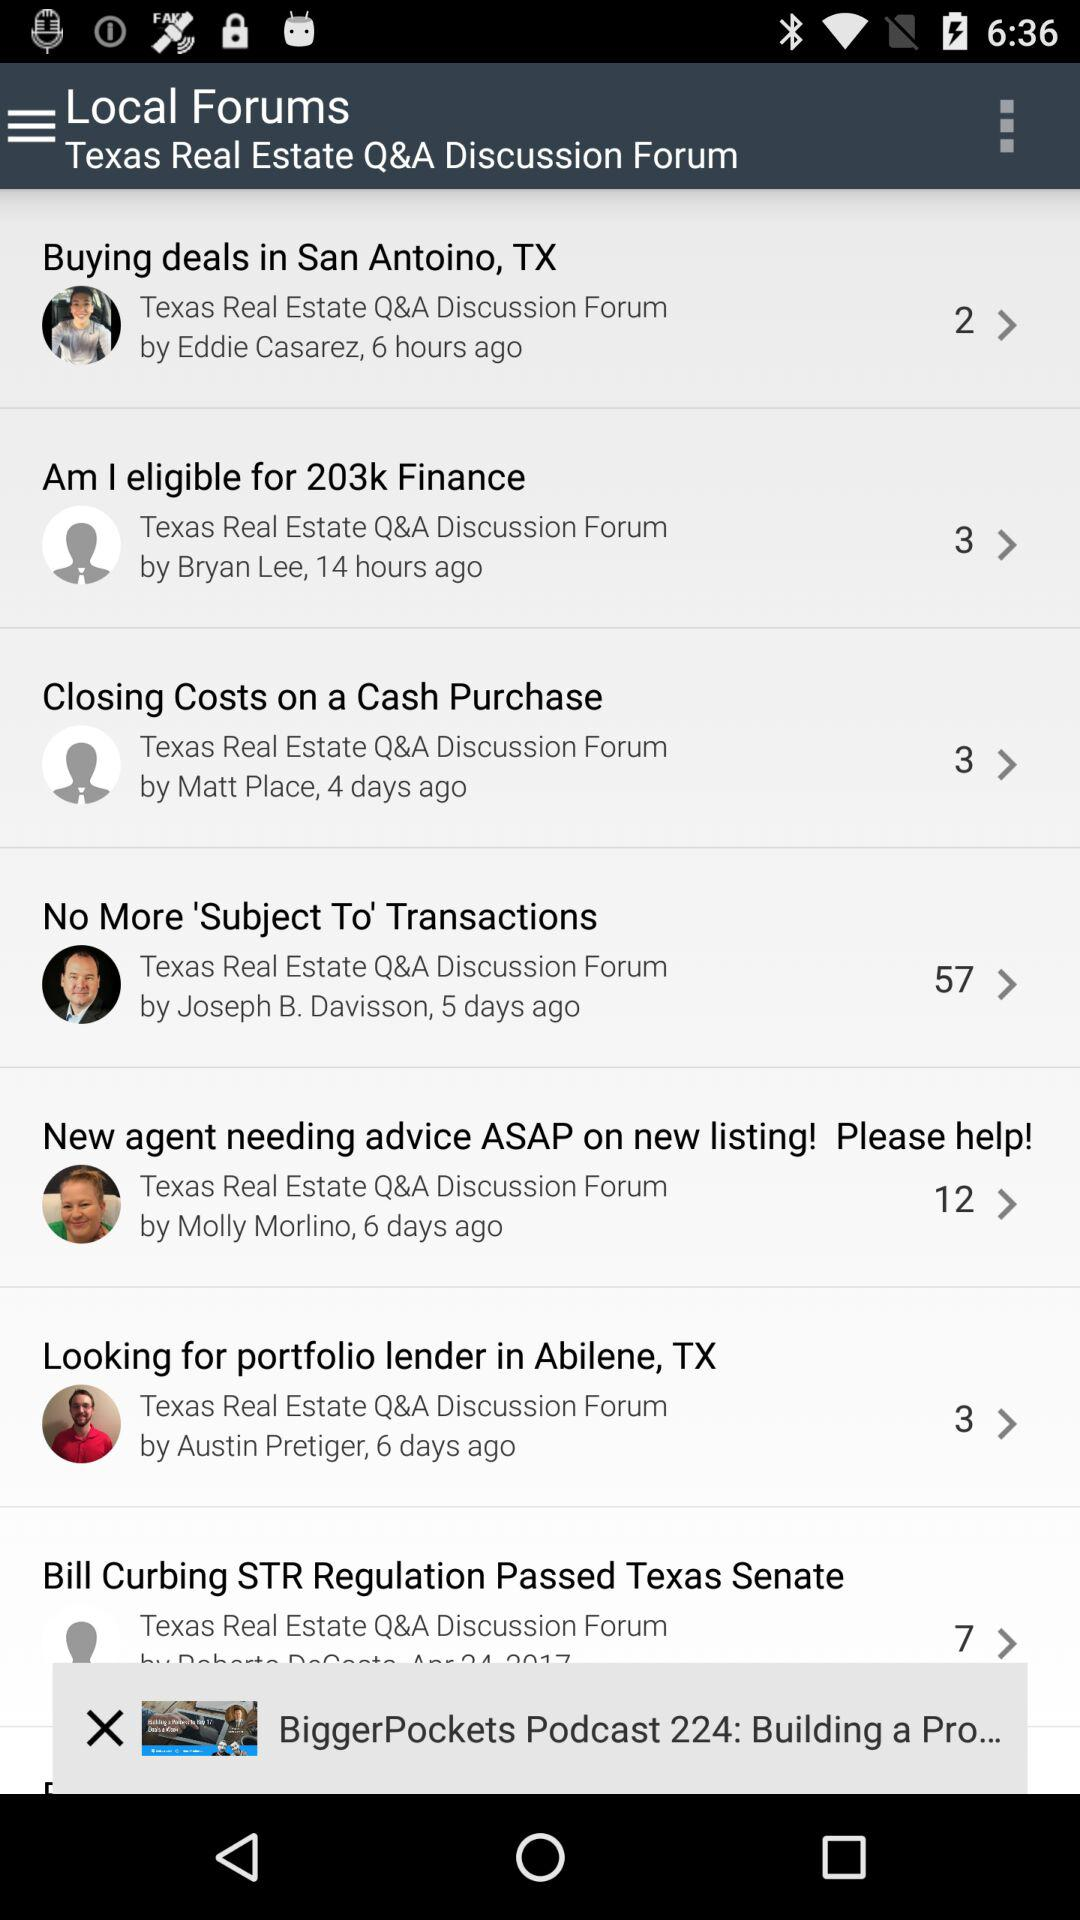By whom was "Closing Costs on a Cash Purchase" posted? "Closing Costs on a Cash Purchase" was posted by Matt Place. 